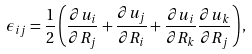Convert formula to latex. <formula><loc_0><loc_0><loc_500><loc_500>\epsilon _ { i j } = \frac { 1 } { 2 } \left ( \frac { \partial u _ { i } } { \partial R _ { j } } + \frac { \partial u _ { j } } { \partial R _ { i } } + \frac { \partial u _ { i } } { \partial R _ { k } } \frac { \partial u _ { k } } { \partial R _ { j } } \right ) ,</formula> 